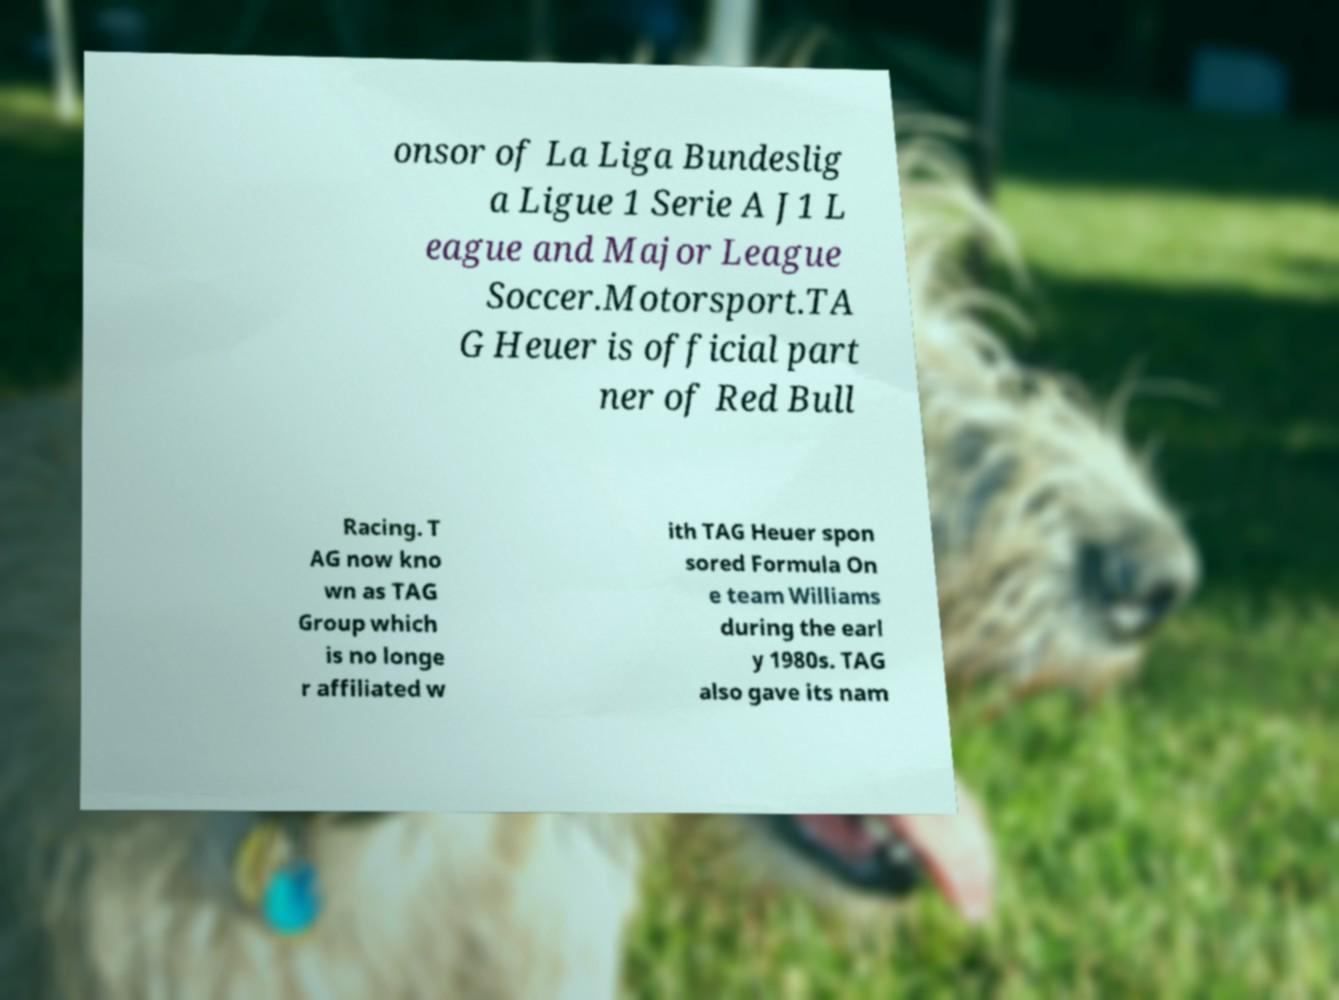Can you read and provide the text displayed in the image?This photo seems to have some interesting text. Can you extract and type it out for me? onsor of La Liga Bundeslig a Ligue 1 Serie A J1 L eague and Major League Soccer.Motorsport.TA G Heuer is official part ner of Red Bull Racing. T AG now kno wn as TAG Group which is no longe r affiliated w ith TAG Heuer spon sored Formula On e team Williams during the earl y 1980s. TAG also gave its nam 